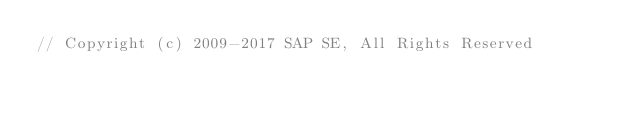<code> <loc_0><loc_0><loc_500><loc_500><_JavaScript_>// Copyright (c) 2009-2017 SAP SE, All Rights Reserved</code> 